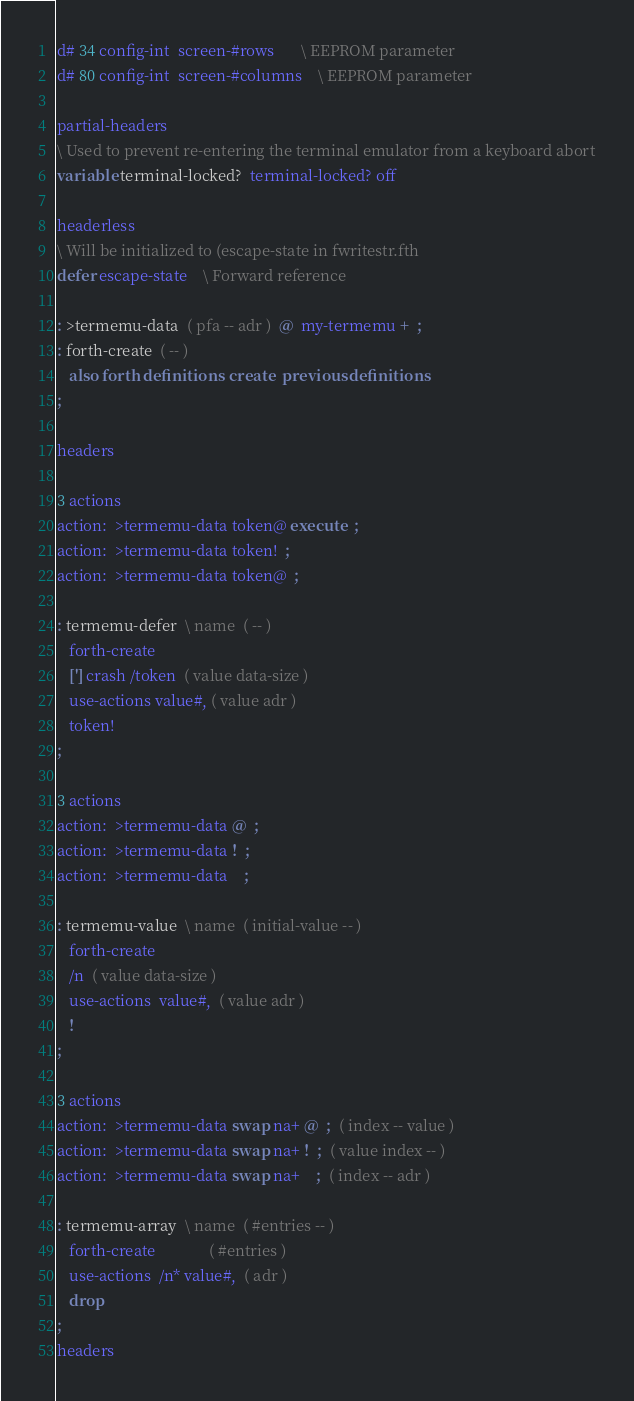Convert code to text. <code><loc_0><loc_0><loc_500><loc_500><_Forth_>d# 34 config-int  screen-#rows       \ EEPROM parameter
d# 80 config-int  screen-#columns    \ EEPROM parameter

partial-headers
\ Used to prevent re-entering the terminal emulator from a keyboard abort
variable terminal-locked?  terminal-locked? off

headerless
\ Will be initialized to (escape-state in fwritestr.fth
defer escape-state	\ Forward reference

: >termemu-data  ( pfa -- adr )  @  my-termemu +  ;
: forth-create  ( -- )
   also forth definitions  create  previous definitions
;

headers

3 actions
action:  >termemu-data token@ execute  ;
action:  >termemu-data token!  ;
action:  >termemu-data token@  ;

: termemu-defer  \ name  ( -- )
   forth-create
   ['] crash /token  ( value data-size )
   use-actions value#, ( value adr )
   token!
;

3 actions
action:  >termemu-data @  ;
action:  >termemu-data !  ;
action:  >termemu-data    ;

: termemu-value  \ name  ( initial-value -- )
   forth-create
   /n  ( value data-size )
   use-actions  value#,  ( value adr )
   !
;

3 actions
action:  >termemu-data swap na+ @  ;  ( index -- value )
action:  >termemu-data swap na+ !  ;  ( value index -- )
action:  >termemu-data swap na+    ;  ( index -- adr )

: termemu-array  \ name  ( #entries -- )
   forth-create              ( #entries )
   use-actions  /n* value#,  ( adr )
   drop
;
headers
</code> 